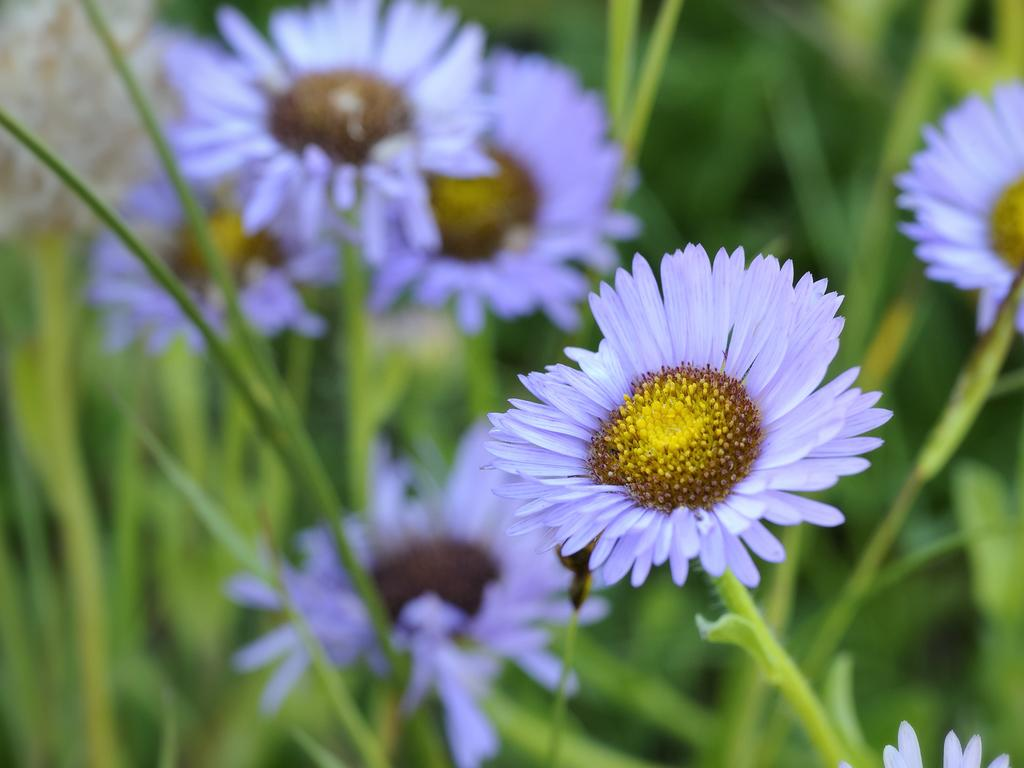What types of living organisms are featured in the image? The picture consists of flowers and plants. What type of wine is being served in the image? There is no wine present in the image; it features flowers and plants. What route is visible in the image? There is no route visible in the image; it features flowers and plants. 